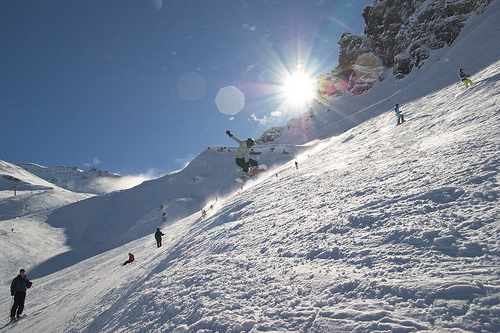How many people were captured in the air? Upon careful observation of the dynamic scene, there are two people captured in mid-air, skillfully performing jumps on their snowboards amidst a breathtaking mountain landscape. 